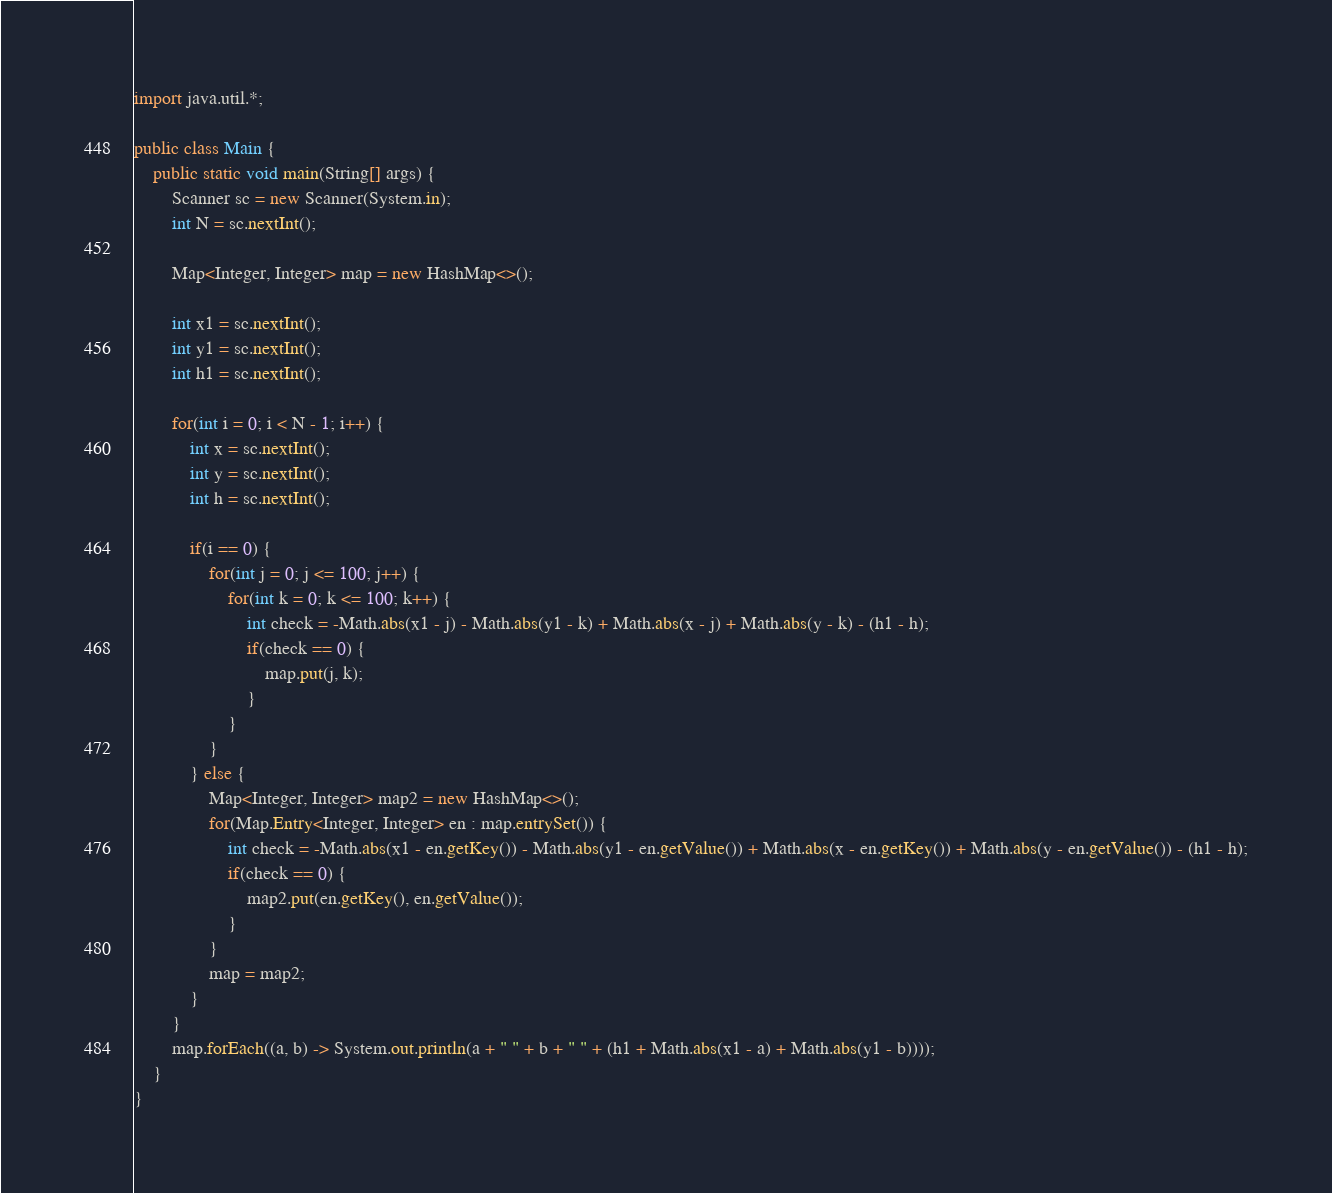Convert code to text. <code><loc_0><loc_0><loc_500><loc_500><_Java_>import java.util.*;

public class Main {
	public static void main(String[] args) {
		Scanner sc = new Scanner(System.in);
		int N = sc.nextInt();
		
		Map<Integer, Integer> map = new HashMap<>();
		
		int x1 = sc.nextInt();
		int y1 = sc.nextInt();
		int h1 = sc.nextInt();
		
		for(int i = 0; i < N - 1; i++) {
			int x = sc.nextInt();
			int y = sc.nextInt();
			int h = sc.nextInt();
			
			if(i == 0) {
				for(int j = 0; j <= 100; j++) {
					for(int k = 0; k <= 100; k++) {
						int check = -Math.abs(x1 - j) - Math.abs(y1 - k) + Math.abs(x - j) + Math.abs(y - k) - (h1 - h);
						if(check == 0) {
							map.put(j, k);
						}
					}
				}
			} else {
				Map<Integer, Integer> map2 = new HashMap<>();
				for(Map.Entry<Integer, Integer> en : map.entrySet()) {
					int check = -Math.abs(x1 - en.getKey()) - Math.abs(y1 - en.getValue()) + Math.abs(x - en.getKey()) + Math.abs(y - en.getValue()) - (h1 - h);
					if(check == 0) {
						map2.put(en.getKey(), en.getValue());
					}
				}
				map = map2;
			}
		}
		map.forEach((a, b) -> System.out.println(a + " " + b + " " + (h1 + Math.abs(x1 - a) + Math.abs(y1 - b))));
	}
}
</code> 